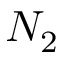Convert formula to latex. <formula><loc_0><loc_0><loc_500><loc_500>N _ { 2 }</formula> 